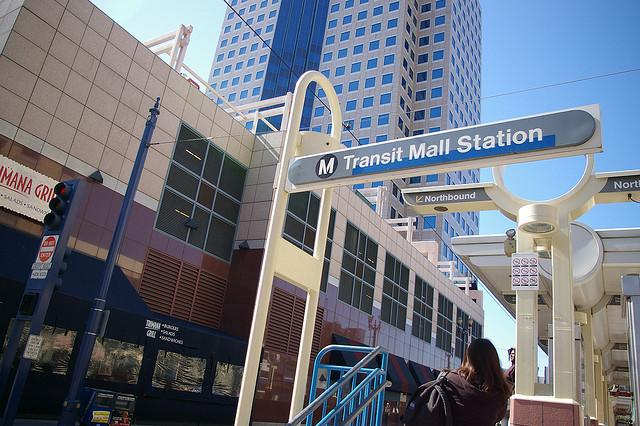What color is the light all the way to the left? red 